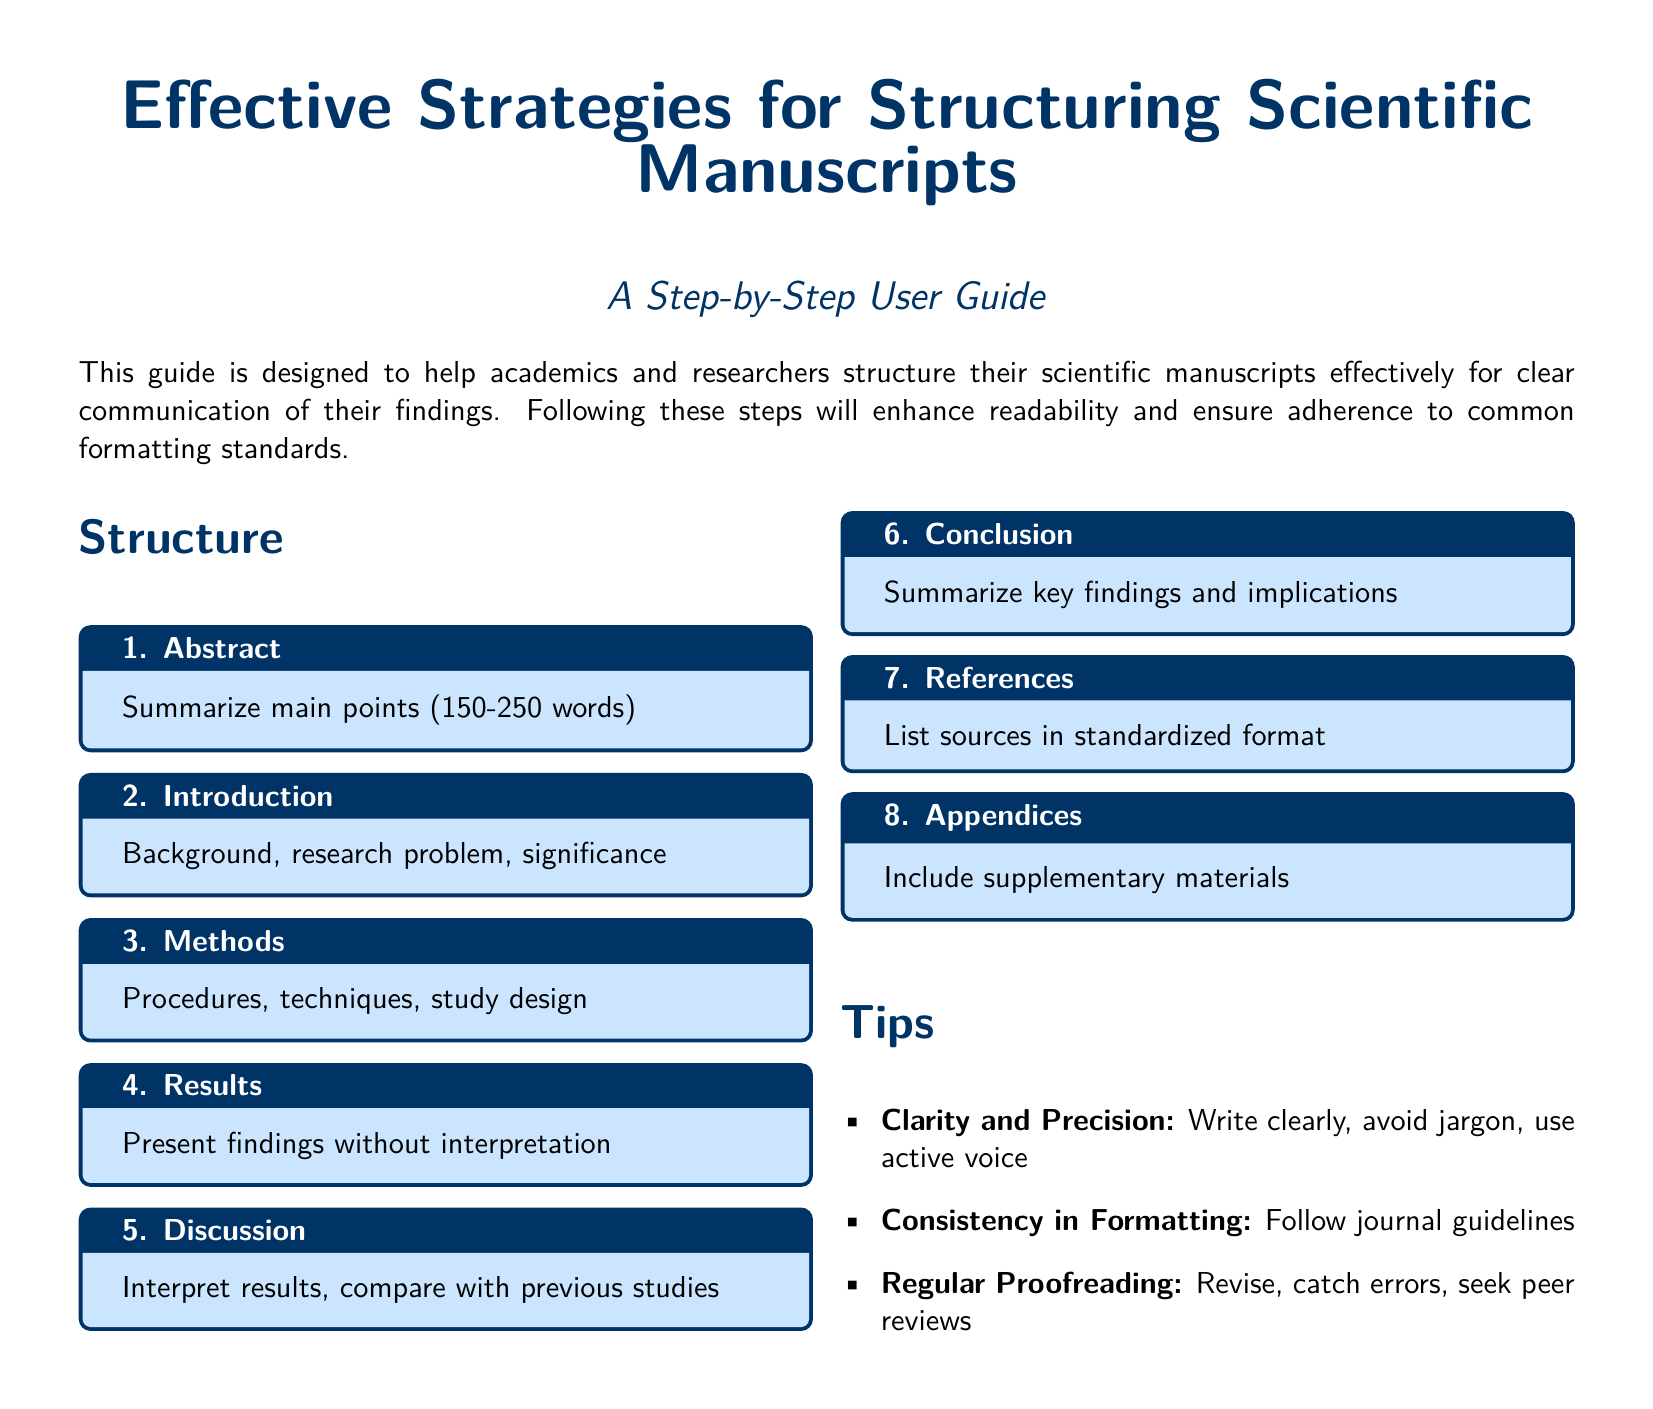What is the recommended word count for the Abstract? The recommended word count for the Abstract is specified in the document as between 150 to 250 words.
Answer: 150-250 words What section includes the study design? The section that includes the study design is mentioned in the document as part of the Methods section.
Answer: Methods What color is used for the section titles? The color used for the section titles is defined as maincolor in the document.
Answer: maincolor How many main sections are outlined in the structure? The total number of main sections outlined in the structure can be counted directly from the document and is seven.
Answer: 7 What does the document suggest for consistency in formatting? The document suggests to follow journal guidelines for consistency in formatting.
Answer: Follow journal guidelines What is the purpose of the guide as stated in the introduction? The purpose of the guide is to help academics and researchers structure their scientific manuscripts effectively.
Answer: Help structure manuscripts What is included in the Appendices section? The document indicates that the Appendices section should include supplementary materials.
Answer: Supplementary materials What is one suggested tip for clarity in writing? One suggested tip for clarity in writing is to write clearly and avoid jargon.
Answer: Write clearly and avoid jargon 